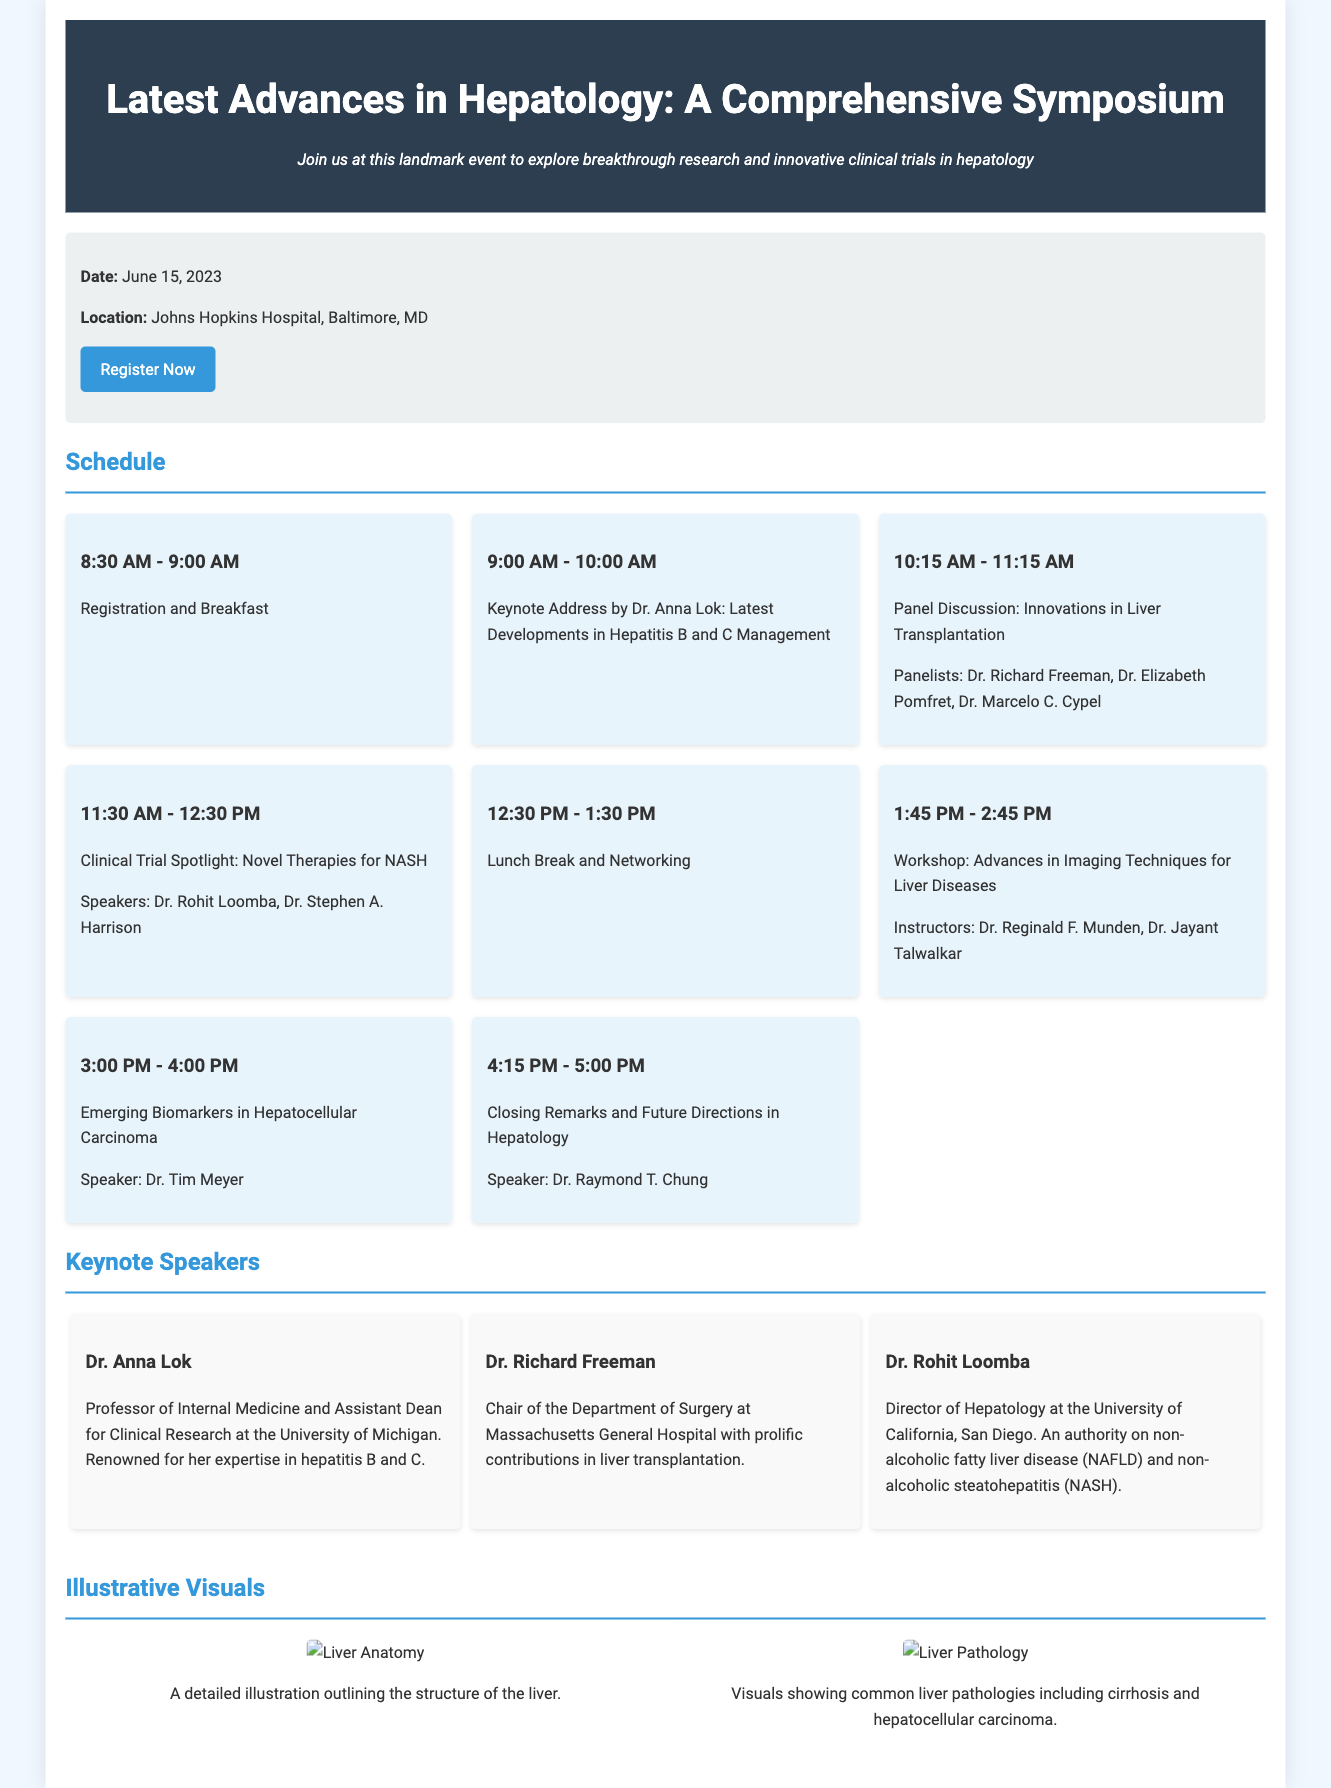What is the date of the symposium? The date is explicitly stated in the document as June 15, 2023.
Answer: June 15, 2023 Where is the symposium located? The location is provided in the document, mentioning Johns Hopkins Hospital, Baltimore, MD.
Answer: Johns Hopkins Hospital, Baltimore, MD Who is the keynote speaker for the address on hepatitis management? The document specifies Dr. Anna Lok as the keynote speaker for this session.
Answer: Dr. Anna Lok What topic will the workshop cover? The workshop topic is mentioned as "Advances in Imaging Techniques for Liver Diseases."
Answer: Advances in Imaging Techniques for Liver Diseases How many schedule items are there before lunch? By counting the schedule items listed before the lunch break, there are four items.
Answer: Four Which speaker is associated with non-alcoholic fatty liver disease? The document identifies Dr. Rohit Loomba as the authority on non-alcoholic fatty liver disease.
Answer: Dr. Rohit Loomba What is depicted in the first illustrative visual? The document describes the first visual as an illustration of the structure of the liver.
Answer: Structure of the liver What is the time slot for the closing remarks? The document clearly states that closing remarks will take place from 4:15 PM to 5:00 PM.
Answer: 4:15 PM - 5:00 PM What type of event is this document promoting? The document serves to promote a symposium focused on hepatology advancements.
Answer: Symposium 